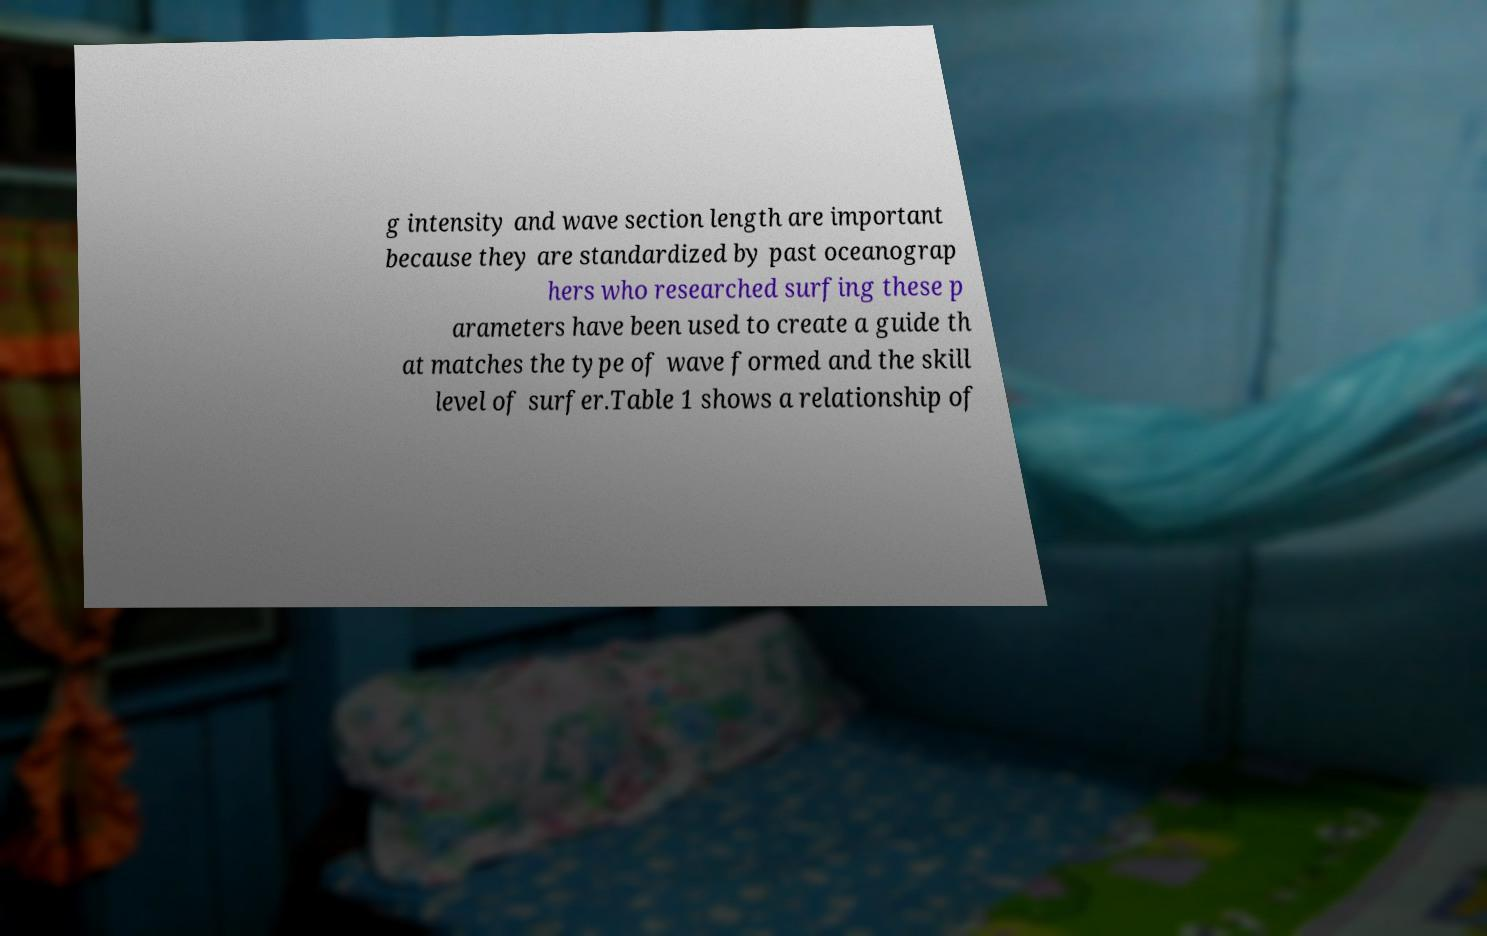There's text embedded in this image that I need extracted. Can you transcribe it verbatim? g intensity and wave section length are important because they are standardized by past oceanograp hers who researched surfing these p arameters have been used to create a guide th at matches the type of wave formed and the skill level of surfer.Table 1 shows a relationship of 